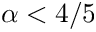<formula> <loc_0><loc_0><loc_500><loc_500>\alpha < 4 / 5</formula> 